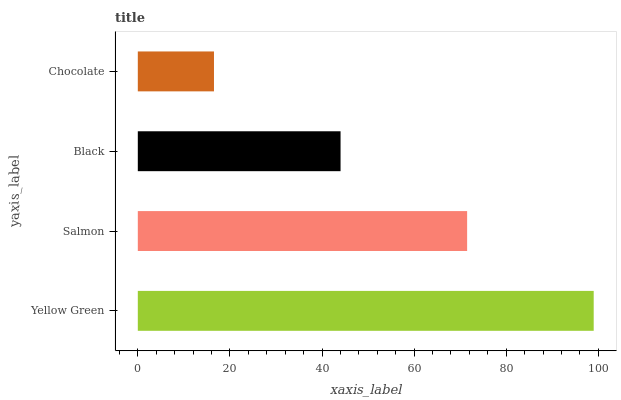Is Chocolate the minimum?
Answer yes or no. Yes. Is Yellow Green the maximum?
Answer yes or no. Yes. Is Salmon the minimum?
Answer yes or no. No. Is Salmon the maximum?
Answer yes or no. No. Is Yellow Green greater than Salmon?
Answer yes or no. Yes. Is Salmon less than Yellow Green?
Answer yes or no. Yes. Is Salmon greater than Yellow Green?
Answer yes or no. No. Is Yellow Green less than Salmon?
Answer yes or no. No. Is Salmon the high median?
Answer yes or no. Yes. Is Black the low median?
Answer yes or no. Yes. Is Yellow Green the high median?
Answer yes or no. No. Is Salmon the low median?
Answer yes or no. No. 